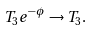<formula> <loc_0><loc_0><loc_500><loc_500>T _ { 3 } e ^ { - \phi } \rightarrow T _ { 3 } .</formula> 